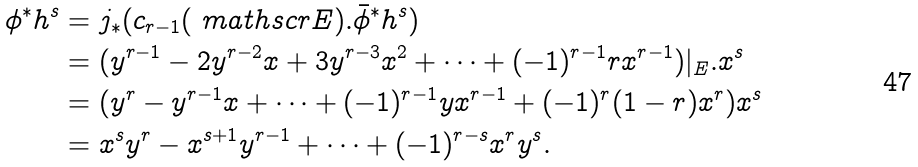<formula> <loc_0><loc_0><loc_500><loc_500>\phi ^ { * } h ^ { s } & = j _ { * } ( c _ { r - 1 } ( \ m a t h s c r { E } ) . \bar { \phi } ^ { * } h ^ { s } ) \\ & = ( y ^ { r - 1 } - 2 y ^ { r - 2 } x + 3 y ^ { r - 3 } x ^ { 2 } + \cdots + ( - 1 ) ^ { r - 1 } r x ^ { r - 1 } ) | _ { E } . x ^ { s } \\ & = ( y ^ { r } - y ^ { r - 1 } x + \cdots + ( - 1 ) ^ { r - 1 } y x ^ { r - 1 } + ( - 1 ) ^ { r } ( 1 - r ) x ^ { r } ) x ^ { s } \\ & = x ^ { s } y ^ { r } - x ^ { s + 1 } y ^ { r - 1 } + \cdots + ( - 1 ) ^ { r - s } x ^ { r } y ^ { s } .</formula> 